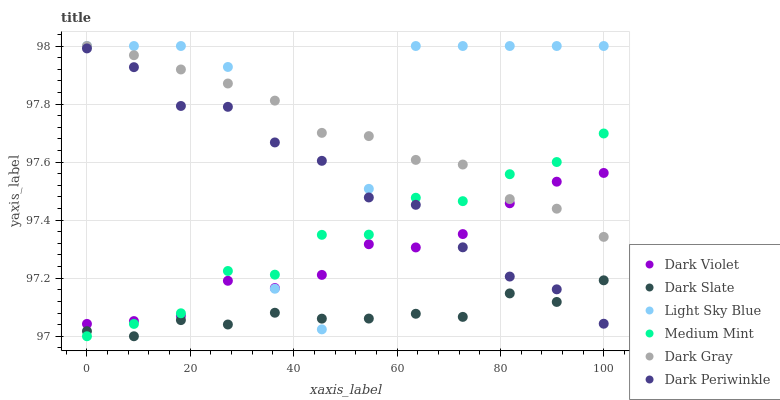Does Dark Slate have the minimum area under the curve?
Answer yes or no. Yes. Does Light Sky Blue have the maximum area under the curve?
Answer yes or no. Yes. Does Dark Violet have the minimum area under the curve?
Answer yes or no. No. Does Dark Violet have the maximum area under the curve?
Answer yes or no. No. Is Dark Gray the smoothest?
Answer yes or no. Yes. Is Light Sky Blue the roughest?
Answer yes or no. Yes. Is Dark Violet the smoothest?
Answer yes or no. No. Is Dark Violet the roughest?
Answer yes or no. No. Does Medium Mint have the lowest value?
Answer yes or no. Yes. Does Dark Violet have the lowest value?
Answer yes or no. No. Does Light Sky Blue have the highest value?
Answer yes or no. Yes. Does Dark Violet have the highest value?
Answer yes or no. No. Is Dark Periwinkle less than Dark Gray?
Answer yes or no. Yes. Is Dark Gray greater than Dark Slate?
Answer yes or no. Yes. Does Dark Violet intersect Light Sky Blue?
Answer yes or no. Yes. Is Dark Violet less than Light Sky Blue?
Answer yes or no. No. Is Dark Violet greater than Light Sky Blue?
Answer yes or no. No. Does Dark Periwinkle intersect Dark Gray?
Answer yes or no. No. 